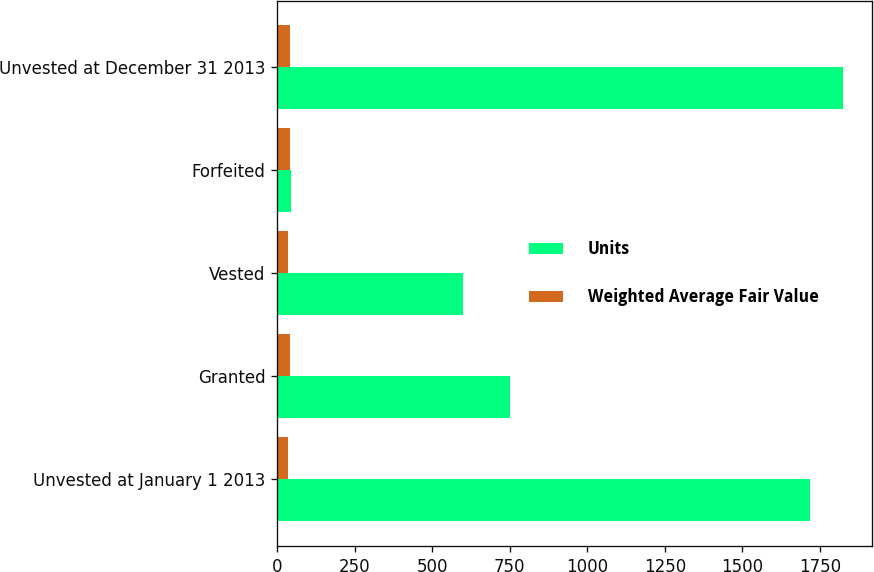Convert chart to OTSL. <chart><loc_0><loc_0><loc_500><loc_500><stacked_bar_chart><ecel><fcel>Unvested at January 1 2013<fcel>Granted<fcel>Vested<fcel>Forfeited<fcel>Unvested at December 31 2013<nl><fcel>Units<fcel>1718<fcel>752<fcel>599<fcel>45<fcel>1826<nl><fcel>Weighted Average Fair Value<fcel>36.2<fcel>43.38<fcel>36.47<fcel>43.43<fcel>43.41<nl></chart> 